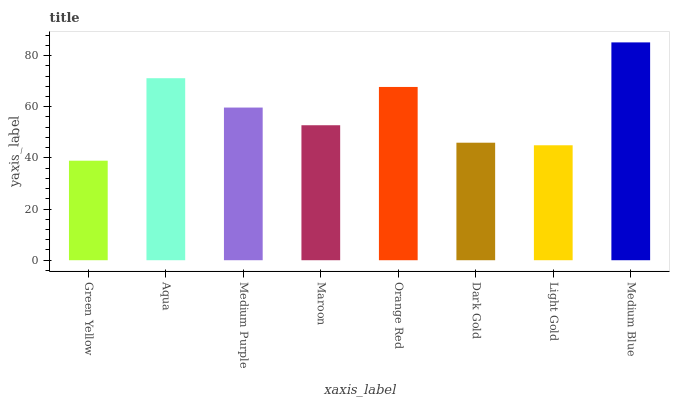Is Aqua the minimum?
Answer yes or no. No. Is Aqua the maximum?
Answer yes or no. No. Is Aqua greater than Green Yellow?
Answer yes or no. Yes. Is Green Yellow less than Aqua?
Answer yes or no. Yes. Is Green Yellow greater than Aqua?
Answer yes or no. No. Is Aqua less than Green Yellow?
Answer yes or no. No. Is Medium Purple the high median?
Answer yes or no. Yes. Is Maroon the low median?
Answer yes or no. Yes. Is Orange Red the high median?
Answer yes or no. No. Is Dark Gold the low median?
Answer yes or no. No. 